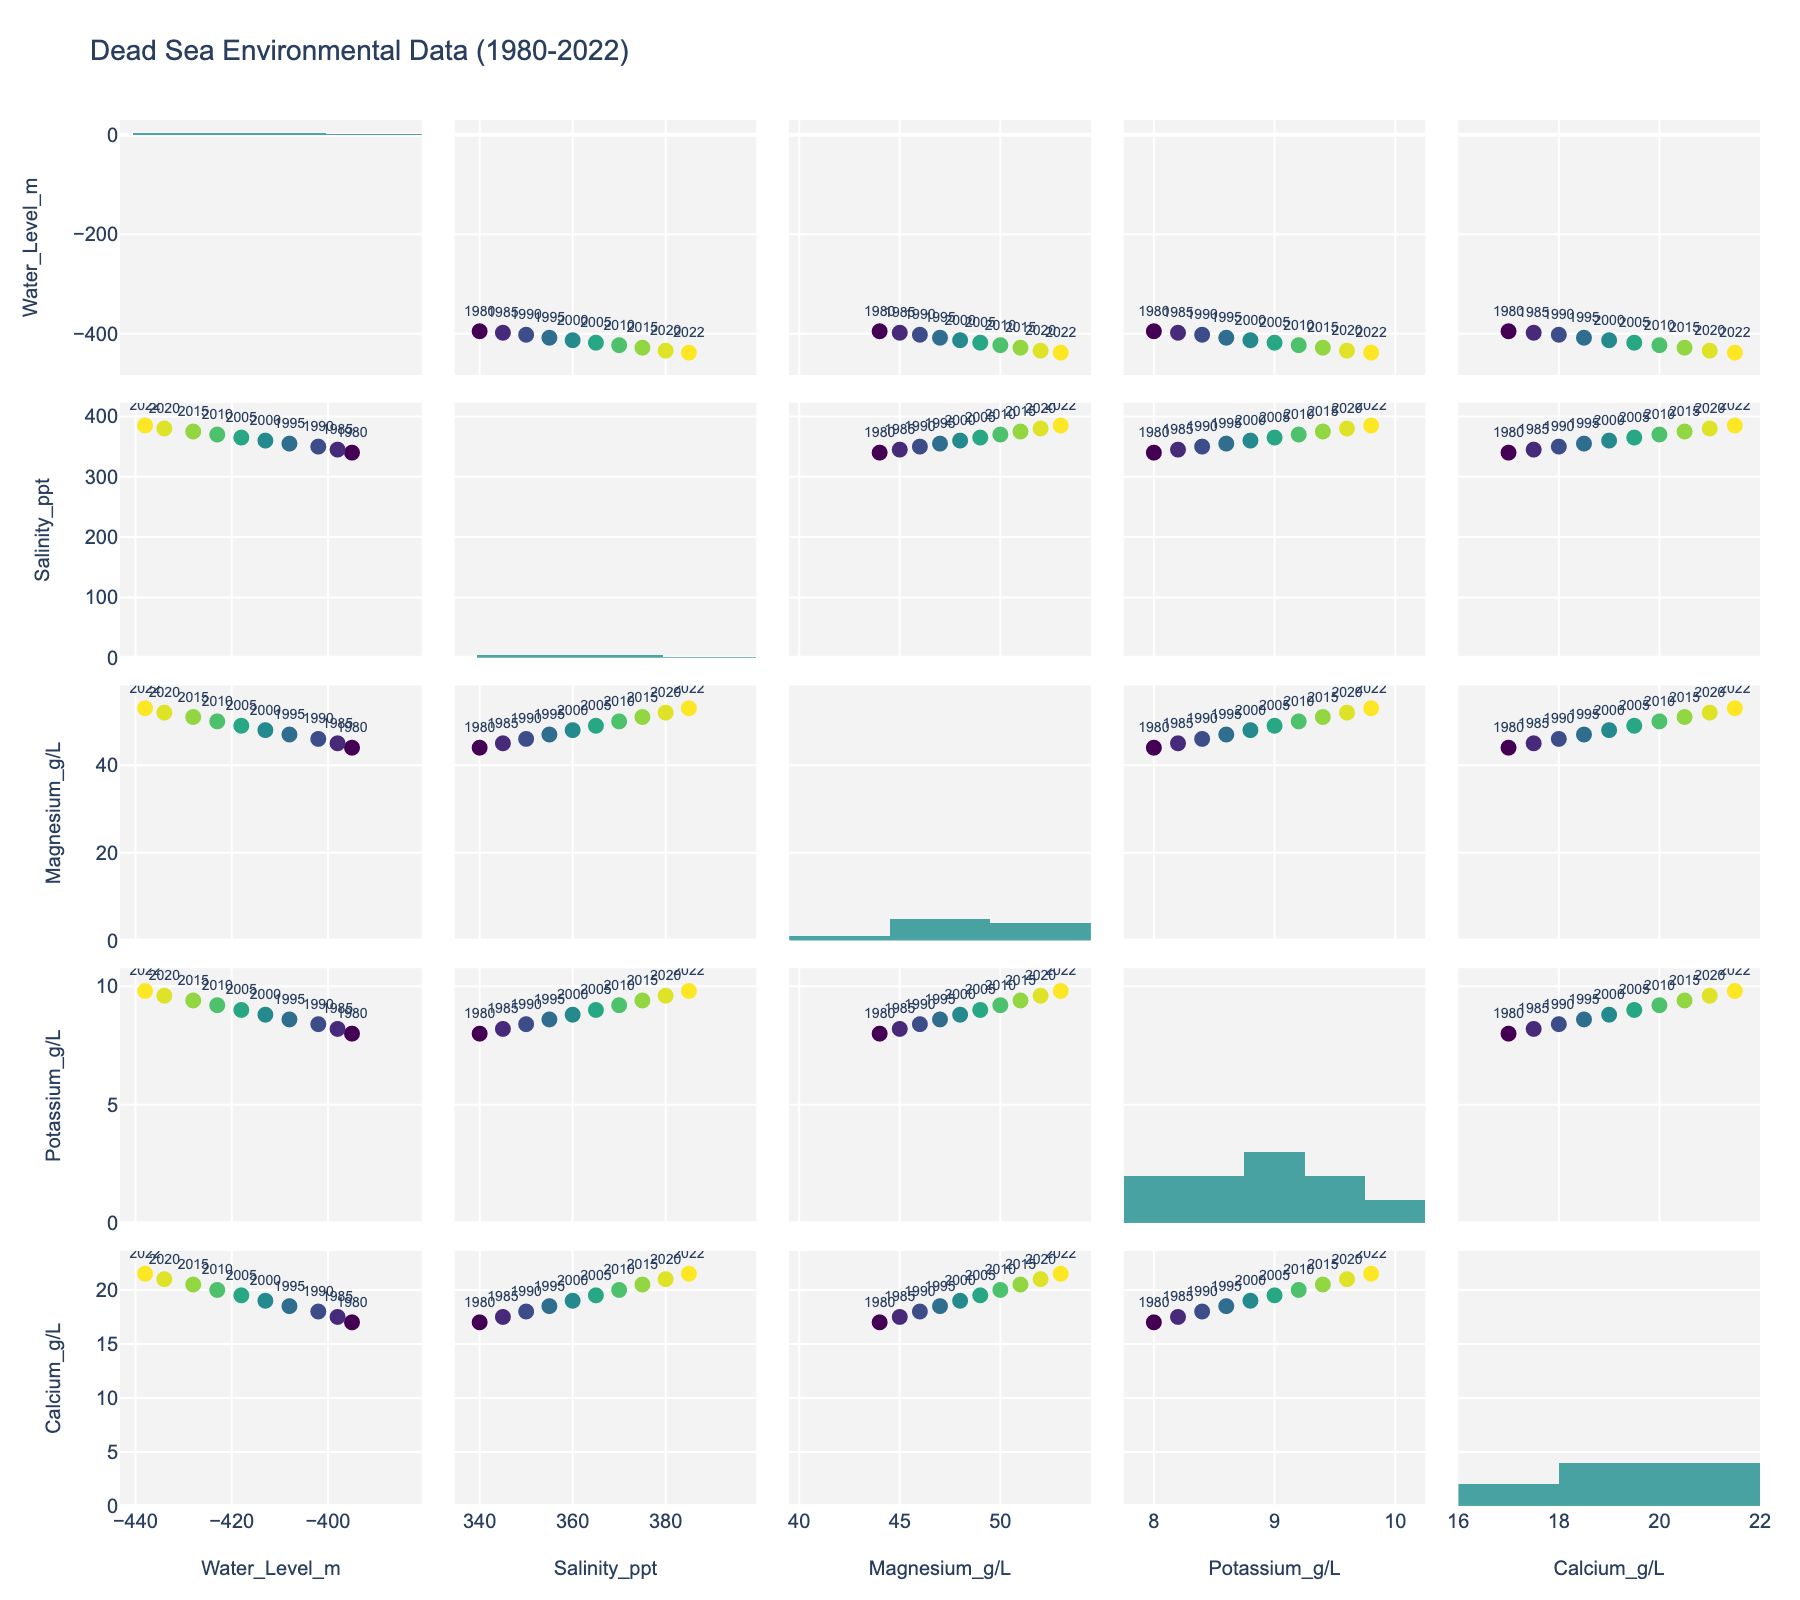What is the title of the scatterplot matrix? The title of the scatterplot matrix is prominently displayed at the top of the figure, indicating the subject or data being visualized.
Answer: Dead Sea Environmental Data (1980-2022) How does water level correlate with salinity over the years? To find the correlation, locate the scatterplot that plots water level on the y-axis against salinity on the x-axis. One can visually assess the trend formed by the data points and the color gradient indicating different years. The trend is a roughly decreasing relationship, meaning as salinity increases, the water level decreases.
Answer: Negative correlation Which variable shows the steepest increase over time? Look at each variable's scatterplots with 'Year' as the color code. The variable with the steepest gradient from one end of the color scale (older years) to the other (recent years) indicates the steepest increase. All minerals show an increase, but Potassium and Salinity show the most prominent steepness.
Answer: Potassium & Salinity In which year did the water level reach -423 meters? Find the histogram for 'Water_Level_m' or locate the scatterplot where the Y-axis corresponds to 'Water_Level_m.' Identify the data point where the water level is -423 and check the corresponding "Year" label.
Answer: 2010 What is the relationship between Magnesium and Potassium concentrations? Locate the scatterplot that has Magnesium on one axis and Potassium on the other. By examining the distribution and trend of the data points, and their color gradient over years, you can determine if there's any positive or negative correlation. The data shows a positive correlation.
Answer: Positive correlation Which year corresponds to the highest Calcium concentration? Check the scatterplot with 'Calcium_g/L' on one axis and 'Year' as the color gradient. Locate the data point with the highest value on the Calcium axis and observe the corresponding color.
Answer: 2022 By how much did the water level decrease between 1980 and 2022? Find the data points corresponding to 1980 and 2022 in the 'Water_Level_m' section. Subtract the water level of 2022 from that of 1980. (1980: -395m, 2022: -438m; Decrease: -438 - (-395) = -43m)
Answer: 43 meters Does Potassium concentration show a linear increase over time? Locate the scatterplots with Potassium on one axis and Year as the color code. Observe if the plot points form a straight-line pattern of increasing value over years. Yes, Potassium shows a consistent increase across the years.
Answer: Yes Which variable shows the least variation over time? Compare the range of the scatterplots for each variable with 'Year' as the color scale. The variable with the smallest span of values from start to end of the time period indicates the least variation.
Answer: Calcium How did the Salinity levels change relative to Magnesium concentration from 1980 to 2022? Locate the scatterplot between Salinity and Magnesium and observe from left to right (representing increase over the years). Salinity and Magnesium have similar increasing trends over time, showing synchronized changes.
Answer: Increased together 